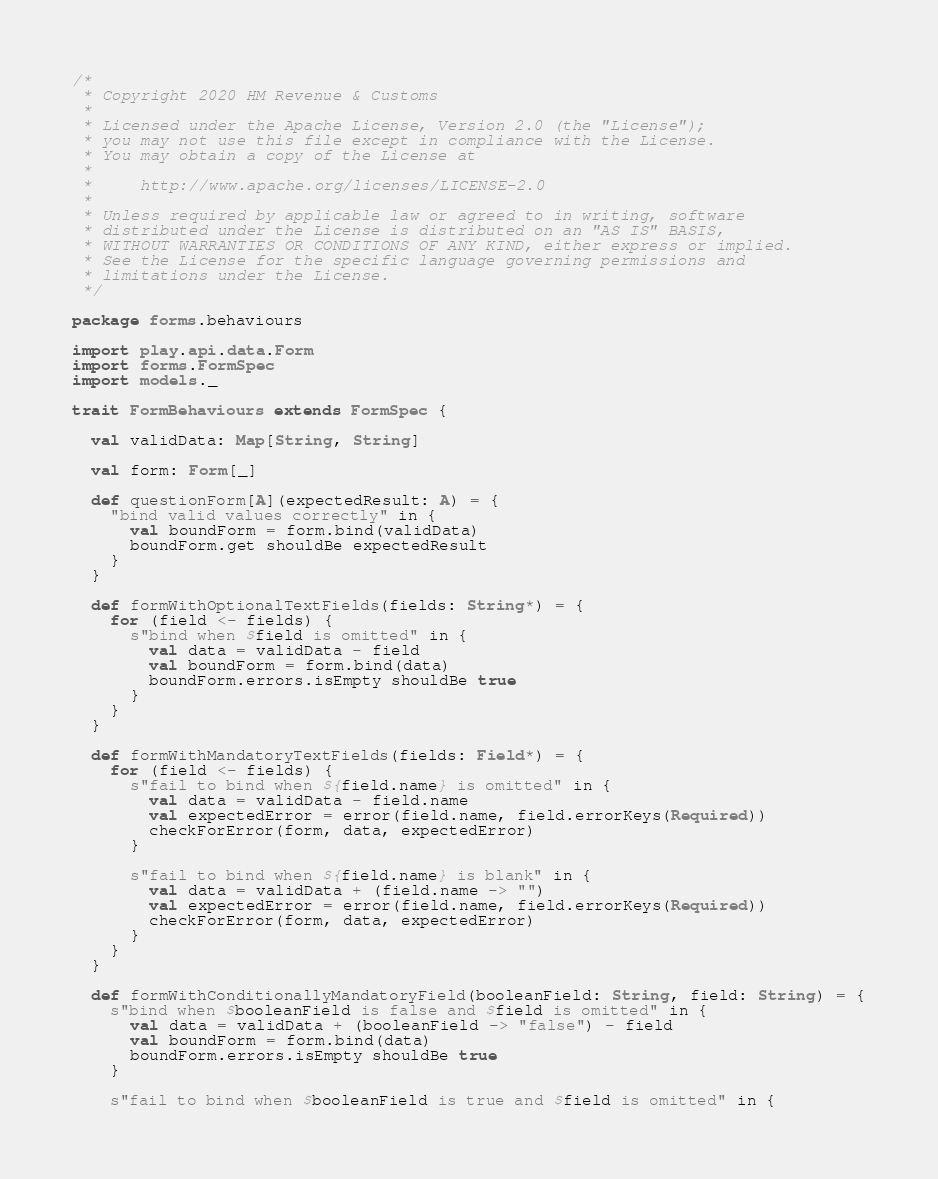<code> <loc_0><loc_0><loc_500><loc_500><_Scala_>/*
 * Copyright 2020 HM Revenue & Customs
 *
 * Licensed under the Apache License, Version 2.0 (the "License");
 * you may not use this file except in compliance with the License.
 * You may obtain a copy of the License at
 *
 *     http://www.apache.org/licenses/LICENSE-2.0
 *
 * Unless required by applicable law or agreed to in writing, software
 * distributed under the License is distributed on an "AS IS" BASIS,
 * WITHOUT WARRANTIES OR CONDITIONS OF ANY KIND, either express or implied.
 * See the License for the specific language governing permissions and
 * limitations under the License.
 */

package forms.behaviours

import play.api.data.Form
import forms.FormSpec
import models._

trait FormBehaviours extends FormSpec {

  val validData: Map[String, String]

  val form: Form[_]

  def questionForm[A](expectedResult: A) = {
    "bind valid values correctly" in {
      val boundForm = form.bind(validData)
      boundForm.get shouldBe expectedResult
    }
  }

  def formWithOptionalTextFields(fields: String*) = {
    for (field <- fields) {
      s"bind when $field is omitted" in {
        val data = validData - field
        val boundForm = form.bind(data)
        boundForm.errors.isEmpty shouldBe true
      }
    }
  }

  def formWithMandatoryTextFields(fields: Field*) = {
    for (field <- fields) {
      s"fail to bind when ${field.name} is omitted" in {
        val data = validData - field.name
        val expectedError = error(field.name, field.errorKeys(Required))
        checkForError(form, data, expectedError)
      }

      s"fail to bind when ${field.name} is blank" in {
        val data = validData + (field.name -> "")
        val expectedError = error(field.name, field.errorKeys(Required))
        checkForError(form, data, expectedError)
      }
    }
  }

  def formWithConditionallyMandatoryField(booleanField: String, field: String) = {
    s"bind when $booleanField is false and $field is omitted" in {
      val data = validData + (booleanField -> "false") - field
      val boundForm = form.bind(data)
      boundForm.errors.isEmpty shouldBe true
    }

    s"fail to bind when $booleanField is true and $field is omitted" in {</code> 